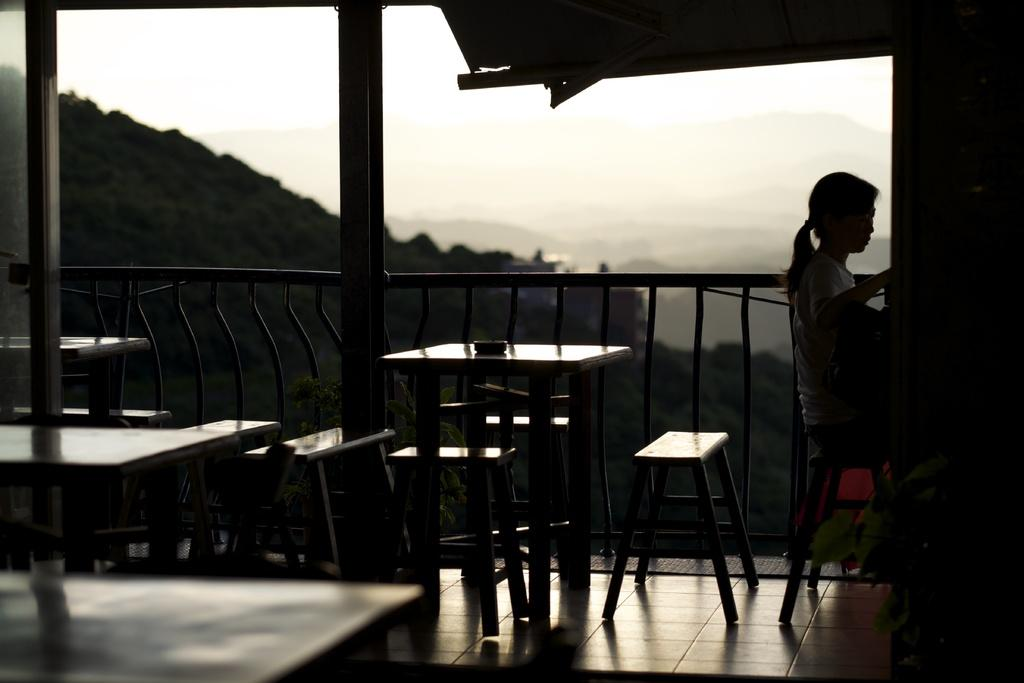What is the woman in the image doing? The woman is seated in the image. On what is the woman seated? The woman is seated on a chair. What type of furniture can be seen in the image? There are tables and chairs in the image. What can be seen in the background of the image? Trees are visible in the image, and the sky is cloudy. What rule is being enforced by the giraffe in the image? There is no giraffe present in the image, so no rule can be enforced by a giraffe. What section of the library is the woman in the image browsing? The image does not depict a library, so it is not possible to determine which section the woman might be browsing. 